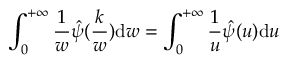Convert formula to latex. <formula><loc_0><loc_0><loc_500><loc_500>\int _ { 0 } ^ { + \infty } \frac { 1 } { w } \hat { \psi } ( \frac { k } { w } ) d w = \int _ { 0 } ^ { + \infty } \frac { 1 } { u } \hat { \psi } ( u ) d u</formula> 